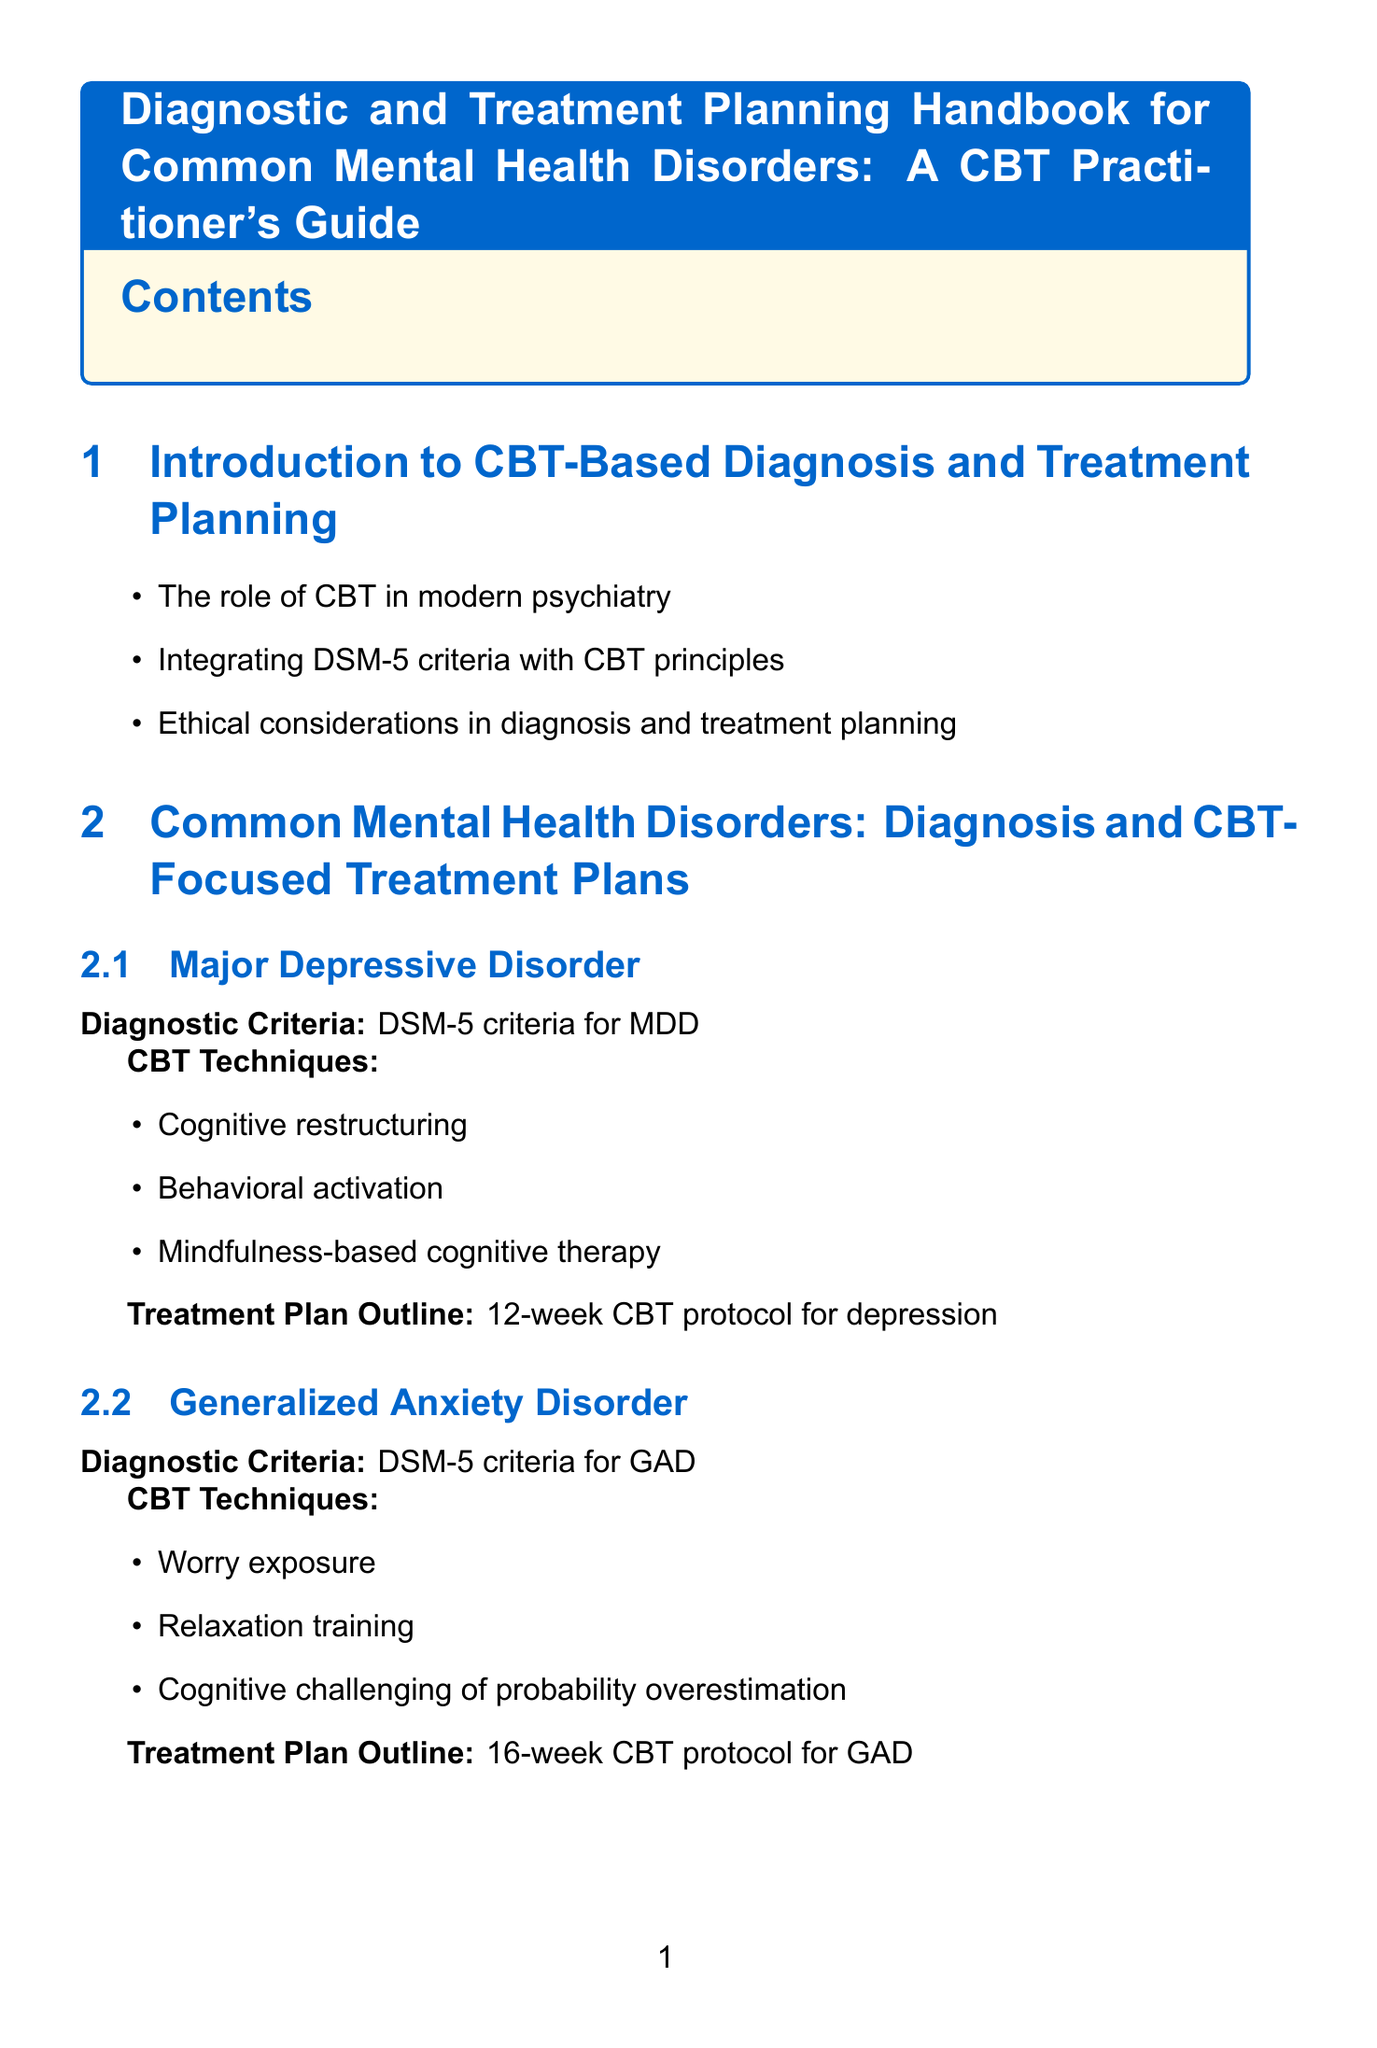what is the title of the document? The title is stated prominently in the opening section of the document.
Answer: Diagnostic and Treatment Planning Handbook for Common Mental Health Disorders: A CBT Practitioner's Guide how many CBT techniques are listed for Generalized Anxiety Disorder? The number of techniques is found in the section on Generalized Anxiety Disorder under CBT techniques.
Answer: 3 what is the total number of weeks for the CBT protocol for Major Depressive Disorder? The duration of the treatment plan is specified in the outline for Major Depressive Disorder.
Answer: 12-week name one tool used for assessing depression severity. The Assessment Tools and Techniques section provides examples of tools for assessment.
Answer: Beck Depression Inventory-II (BDI-II) what is one key concept in Acceptance and Commitment Therapy? Key concepts for newer CBT approaches are listed in the separate subsections of the document.
Answer: Psychological flexibility how many common mental health disorders are covered in the document? The number of disorders included is indicated in the section dedicated to Common Mental Health Disorders.
Answer: 3 what therapeutic approach focuses on distress tolerance? The question references one of the newer CBT approaches outlined in the document.
Answer: Dialectical Behavior Therapy (DBT) what is the purpose of using SMART goals in treatment planning? The Treatment Planning and Goal Setting section explains the framework's purpose.
Answer: Prioritizing treatment targets 